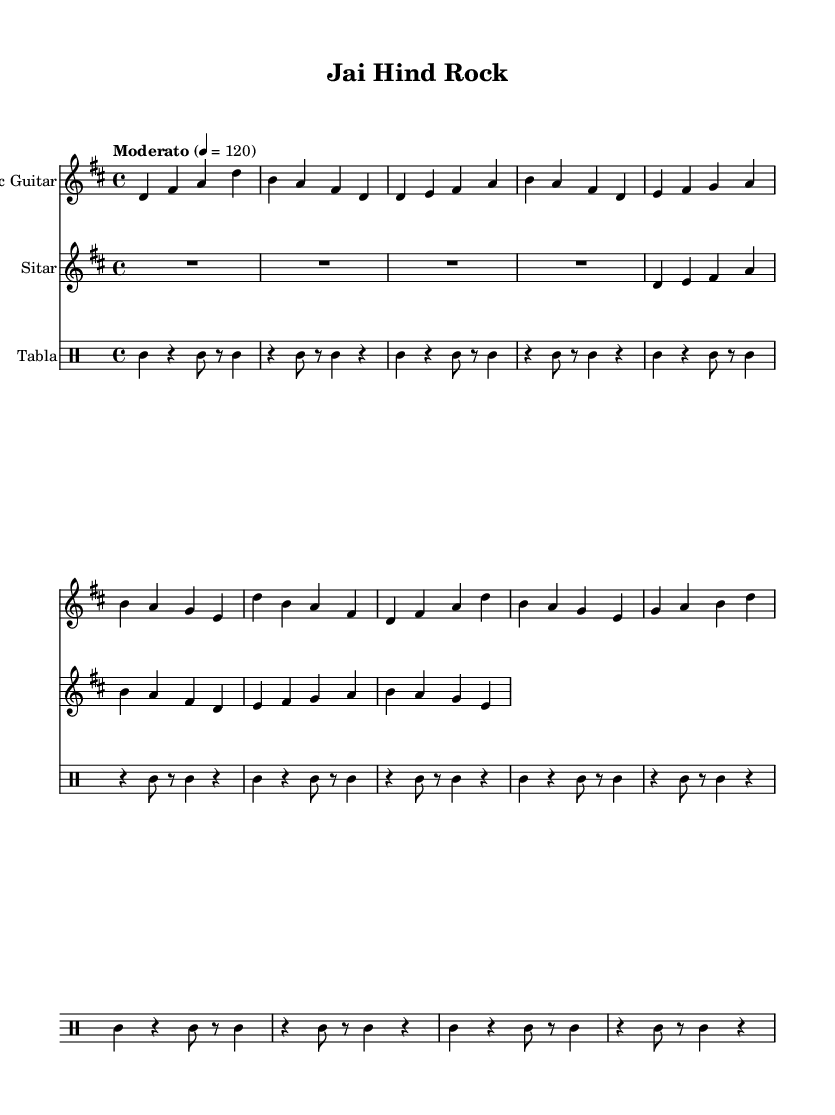What is the key signature of this music? The key signature shows two sharps, which indicate that the key is D major.
Answer: D major What is the time signature of this music? The time signature is indicated at the beginning of the score as 4/4, meaning there are four beats in each measure and the quarter note gets one beat.
Answer: 4/4 What is the tempo marking of this piece? The tempo marking at the beginning states "Moderato" with a metronome marking of 120, indicating a moderate speed.
Answer: Moderato How many measures are present in the electric guitar part? Counting the measures in the electric guitar part, there are a total of eight measures visible in the sheet music.
Answer: Eight What instruments are featured in this composition? The score includes three instruments: electric guitar, sitar, and tabla.
Answer: Electric guitar, sitar, tabla What rhythmic pattern is predominantly used in the tabla part? The tabla part predominantly features a repeated rhythmic pattern, alternating between quarter notes and rests, specifically a combination of quarter-note strikes and eighth-note rests.
Answer: Repeated quarter and eighth notes Why is the sitar part important in this fusion piece? The sitar part adds a distinct melodic layer characteristic of Indian classical music, complementing the rock elements from the electric guitar and enhancing the fusion style.
Answer: Adds melodic layer 